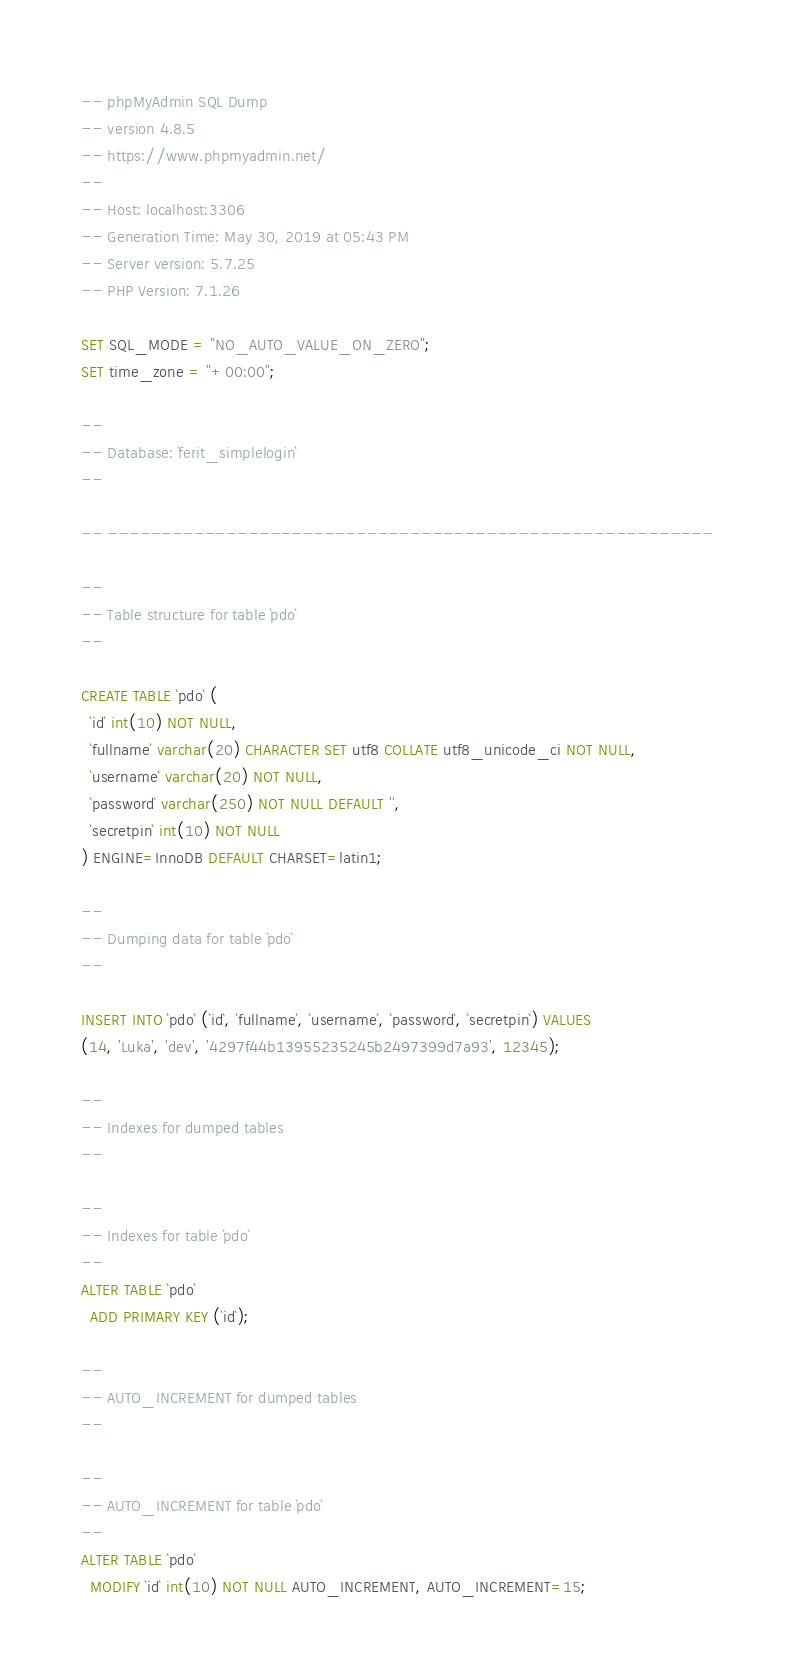Convert code to text. <code><loc_0><loc_0><loc_500><loc_500><_SQL_>-- phpMyAdmin SQL Dump
-- version 4.8.5
-- https://www.phpmyadmin.net/
--
-- Host: localhost:3306
-- Generation Time: May 30, 2019 at 05:43 PM
-- Server version: 5.7.25
-- PHP Version: 7.1.26

SET SQL_MODE = "NO_AUTO_VALUE_ON_ZERO";
SET time_zone = "+00:00";

--
-- Database: `ferit_simplelogin`
--

-- --------------------------------------------------------

--
-- Table structure for table `pdo`
--

CREATE TABLE `pdo` (
  `id` int(10) NOT NULL,
  `fullname` varchar(20) CHARACTER SET utf8 COLLATE utf8_unicode_ci NOT NULL,
  `username` varchar(20) NOT NULL,
  `password` varchar(250) NOT NULL DEFAULT '',
  `secretpin` int(10) NOT NULL
) ENGINE=InnoDB DEFAULT CHARSET=latin1;

--
-- Dumping data for table `pdo`
--

INSERT INTO `pdo` (`id`, `fullname`, `username`, `password`, `secretpin`) VALUES
(14, 'Luka', 'dev', '4297f44b13955235245b2497399d7a93', 12345);

--
-- Indexes for dumped tables
--

--
-- Indexes for table `pdo`
--
ALTER TABLE `pdo`
  ADD PRIMARY KEY (`id`);

--
-- AUTO_INCREMENT for dumped tables
--

--
-- AUTO_INCREMENT for table `pdo`
--
ALTER TABLE `pdo`
  MODIFY `id` int(10) NOT NULL AUTO_INCREMENT, AUTO_INCREMENT=15;
</code> 